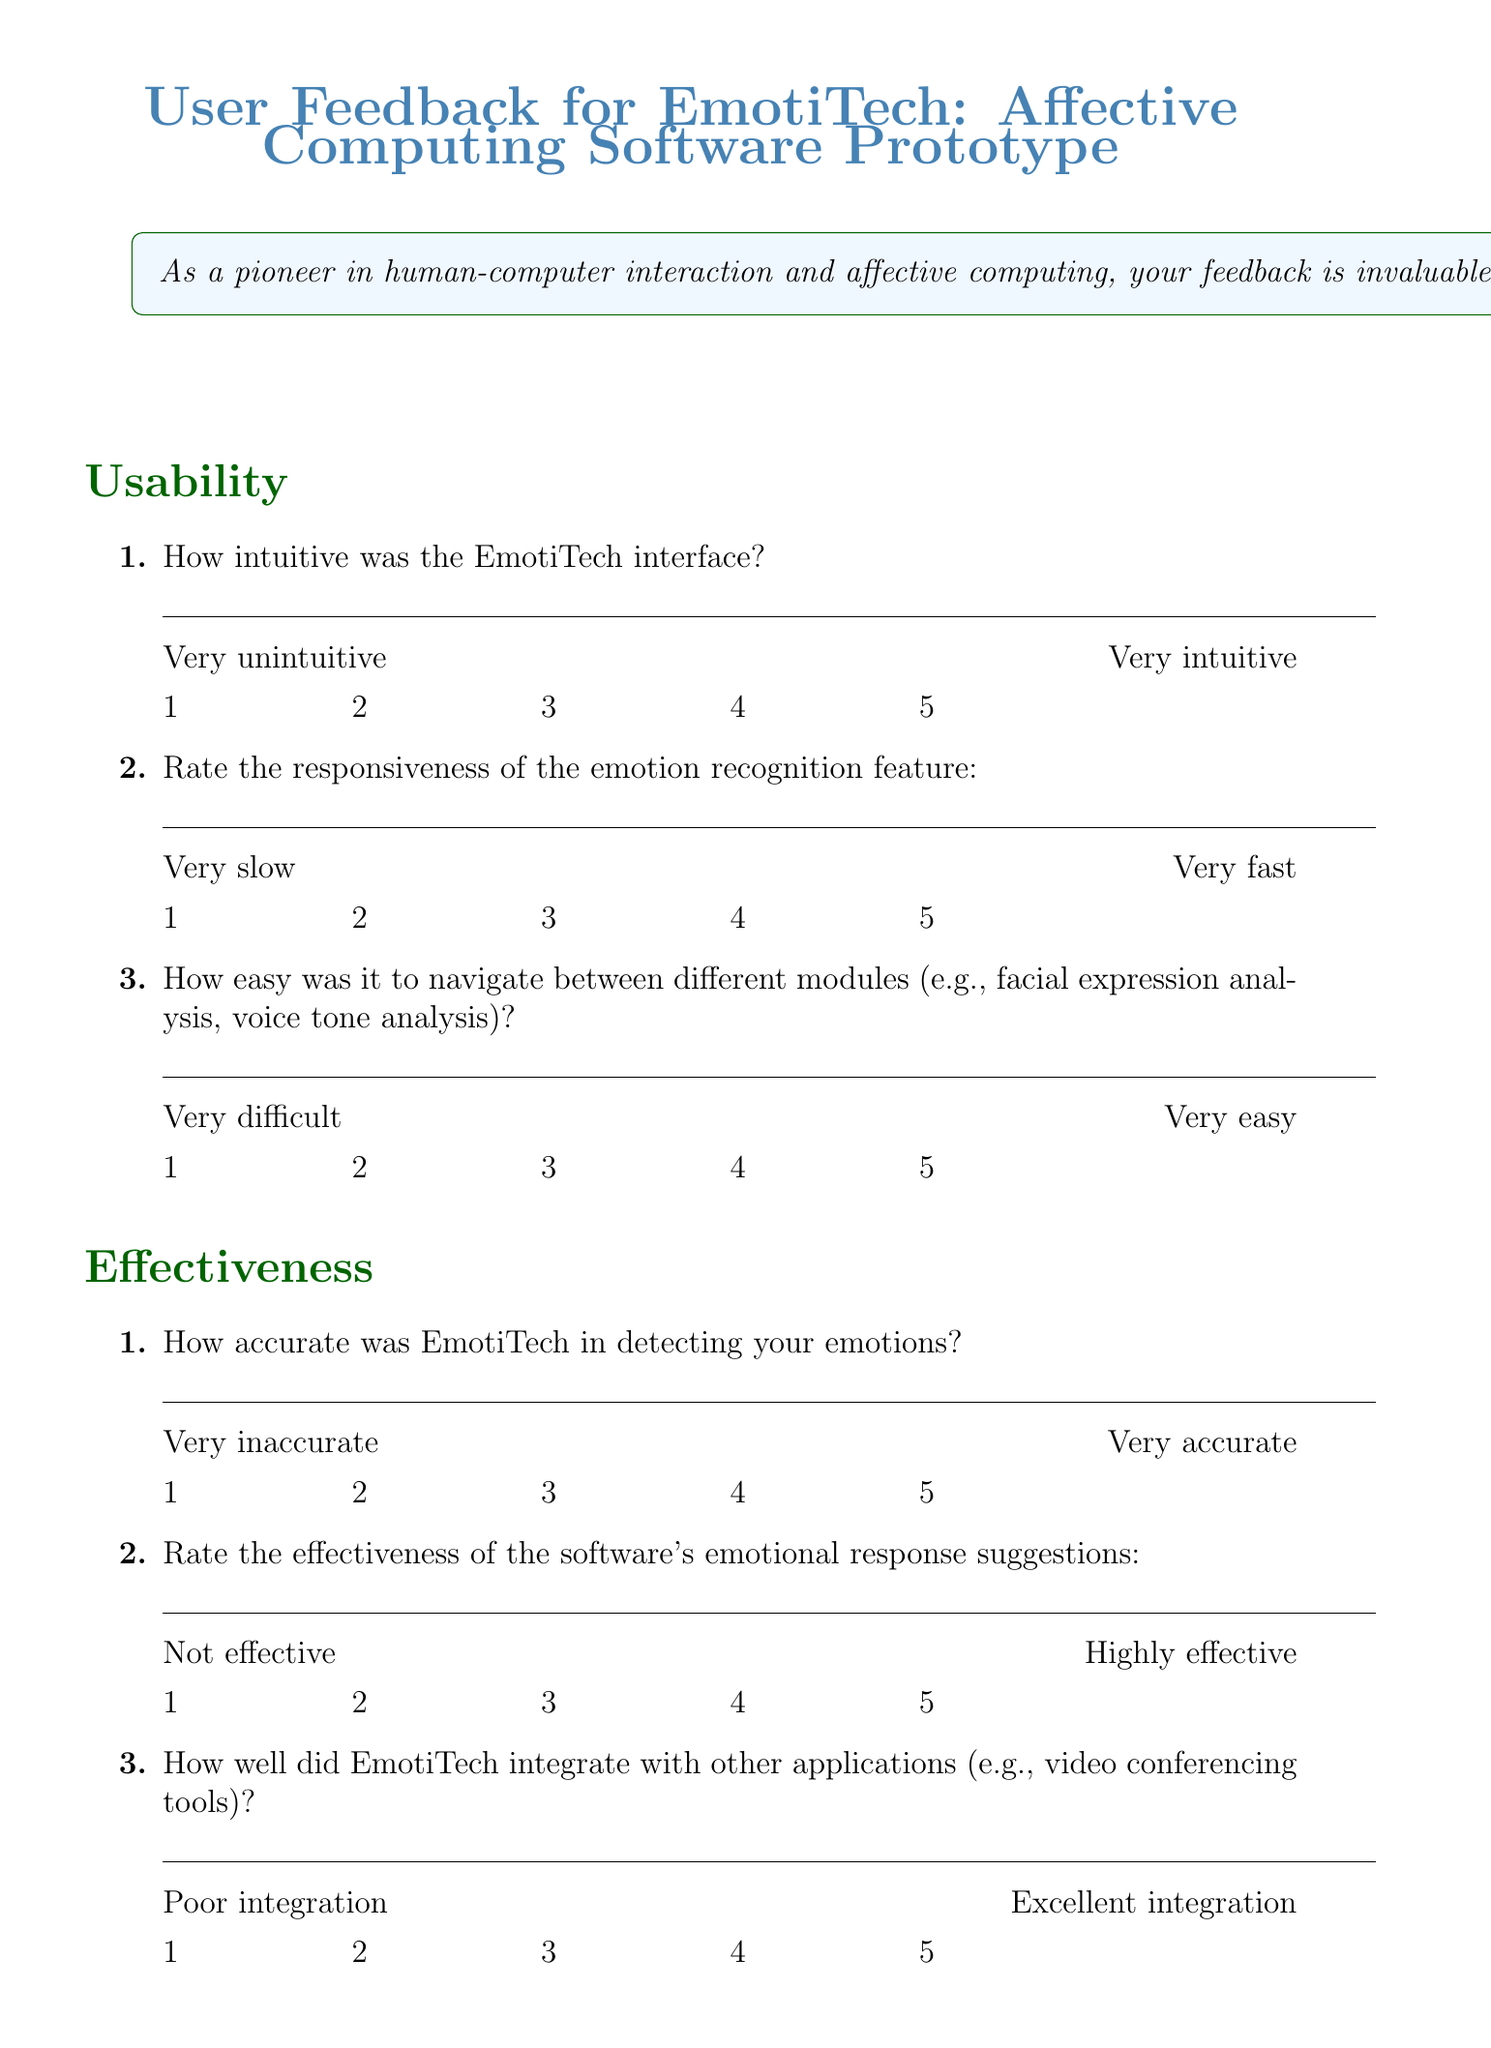What is the title of the feedback form? The title is stated at the beginning of the document.
Answer: User Feedback for EmotiTech: Affective Computing Software Prototype How many sections are there in the form? The number of sections is listed in the structure of the document.
Answer: Five What scale is used for the usability ratings? The document specifies the range of the rating scale for usability.
Answer: 1 to 5 Which feature is specifically evaluated in the "Specific Features" section? The features evaluated in this section are outlined clearly in the document.
Answer: Facial micro-expression detection algorithm What does the introduction ask participants to evaluate? The introduction states what feedback the participants are required to provide.
Answer: The new software prototype, EmotiTech How does the conclusion express gratitude? The conclusion section explains how appreciation is conveyed.
Answer: Thank you for your valuable feedback 